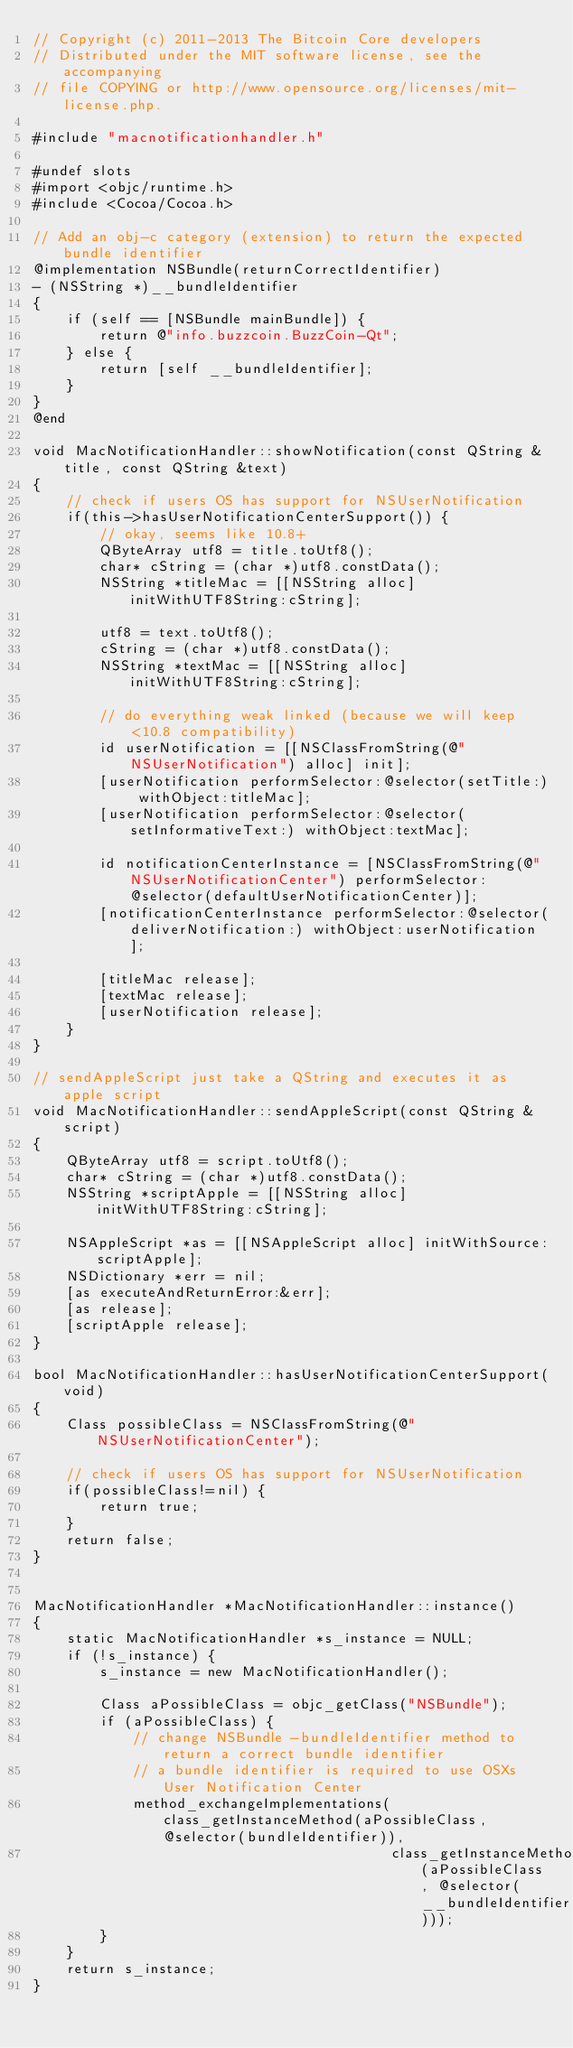<code> <loc_0><loc_0><loc_500><loc_500><_ObjectiveC_>// Copyright (c) 2011-2013 The Bitcoin Core developers
// Distributed under the MIT software license, see the accompanying
// file COPYING or http://www.opensource.org/licenses/mit-license.php.

#include "macnotificationhandler.h"

#undef slots
#import <objc/runtime.h>
#include <Cocoa/Cocoa.h>

// Add an obj-c category (extension) to return the expected bundle identifier
@implementation NSBundle(returnCorrectIdentifier)
- (NSString *)__bundleIdentifier
{
    if (self == [NSBundle mainBundle]) {
        return @"info.buzzcoin.BuzzCoin-Qt";
    } else {
        return [self __bundleIdentifier];
    }
}
@end

void MacNotificationHandler::showNotification(const QString &title, const QString &text)
{
    // check if users OS has support for NSUserNotification
    if(this->hasUserNotificationCenterSupport()) {
        // okay, seems like 10.8+
        QByteArray utf8 = title.toUtf8();
        char* cString = (char *)utf8.constData();
        NSString *titleMac = [[NSString alloc] initWithUTF8String:cString];

        utf8 = text.toUtf8();
        cString = (char *)utf8.constData();
        NSString *textMac = [[NSString alloc] initWithUTF8String:cString];

        // do everything weak linked (because we will keep <10.8 compatibility)
        id userNotification = [[NSClassFromString(@"NSUserNotification") alloc] init];
        [userNotification performSelector:@selector(setTitle:) withObject:titleMac];
        [userNotification performSelector:@selector(setInformativeText:) withObject:textMac];

        id notificationCenterInstance = [NSClassFromString(@"NSUserNotificationCenter") performSelector:@selector(defaultUserNotificationCenter)];
        [notificationCenterInstance performSelector:@selector(deliverNotification:) withObject:userNotification];

        [titleMac release];
        [textMac release];
        [userNotification release];
    }
}

// sendAppleScript just take a QString and executes it as apple script
void MacNotificationHandler::sendAppleScript(const QString &script)
{
    QByteArray utf8 = script.toUtf8();
    char* cString = (char *)utf8.constData();
    NSString *scriptApple = [[NSString alloc] initWithUTF8String:cString];

    NSAppleScript *as = [[NSAppleScript alloc] initWithSource:scriptApple];
    NSDictionary *err = nil;
    [as executeAndReturnError:&err];
    [as release];
    [scriptApple release];
}

bool MacNotificationHandler::hasUserNotificationCenterSupport(void)
{
    Class possibleClass = NSClassFromString(@"NSUserNotificationCenter");

    // check if users OS has support for NSUserNotification
    if(possibleClass!=nil) {
        return true;
    }
    return false;
}


MacNotificationHandler *MacNotificationHandler::instance()
{
    static MacNotificationHandler *s_instance = NULL;
    if (!s_instance) {
        s_instance = new MacNotificationHandler();

        Class aPossibleClass = objc_getClass("NSBundle");
        if (aPossibleClass) {
            // change NSBundle -bundleIdentifier method to return a correct bundle identifier
            // a bundle identifier is required to use OSXs User Notification Center
            method_exchangeImplementations(class_getInstanceMethod(aPossibleClass, @selector(bundleIdentifier)),
                                           class_getInstanceMethod(aPossibleClass, @selector(__bundleIdentifier)));
        }
    }
    return s_instance;
}
</code> 